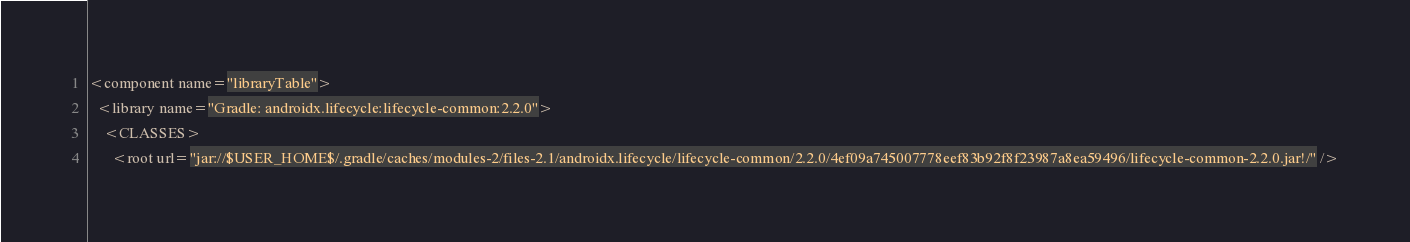Convert code to text. <code><loc_0><loc_0><loc_500><loc_500><_XML_><component name="libraryTable">
  <library name="Gradle: androidx.lifecycle:lifecycle-common:2.2.0">
    <CLASSES>
      <root url="jar://$USER_HOME$/.gradle/caches/modules-2/files-2.1/androidx.lifecycle/lifecycle-common/2.2.0/4ef09a745007778eef83b92f8f23987a8ea59496/lifecycle-common-2.2.0.jar!/" /></code> 